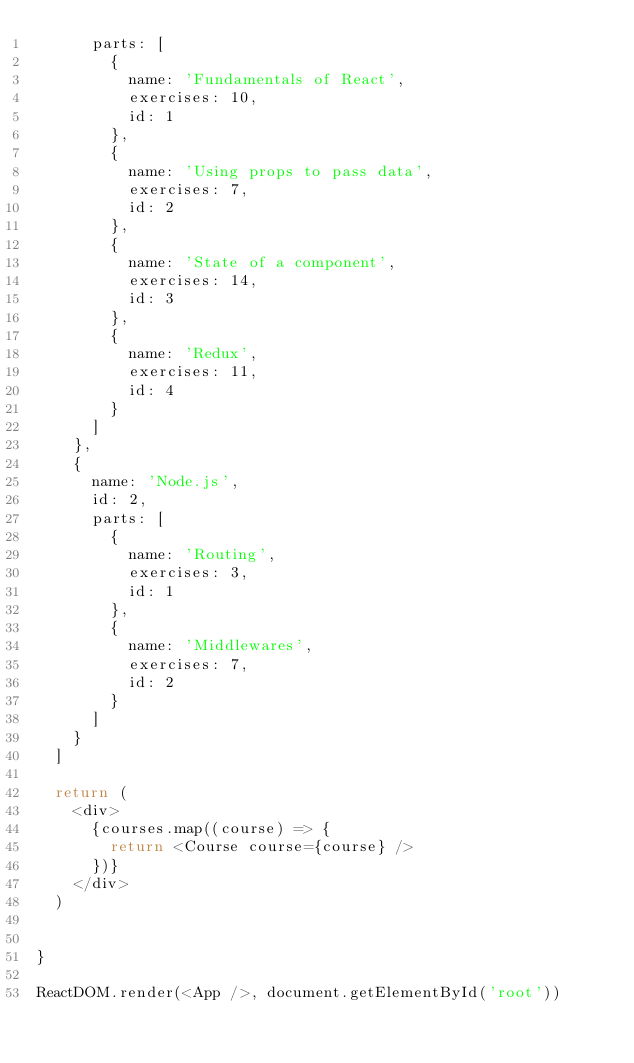Convert code to text. <code><loc_0><loc_0><loc_500><loc_500><_JavaScript_>      parts: [
        {
          name: 'Fundamentals of React',
          exercises: 10,
          id: 1
        },
        {
          name: 'Using props to pass data',
          exercises: 7,
          id: 2
        },
        {
          name: 'State of a component',
          exercises: 14,
          id: 3
        },
        {
          name: 'Redux',
          exercises: 11,
          id: 4
        }
      ]
    }, 
    {
      name: 'Node.js',
      id: 2,
      parts: [
        {
          name: 'Routing',
          exercises: 3,
          id: 1
        },
        {
          name: 'Middlewares',
          exercises: 7,
          id: 2
        }
      ]
    }
  ]

  return (
    <div>
      {courses.map((course) => {
        return <Course course={course} />
      })}
    </div>
  )
  
  
}

ReactDOM.render(<App />, document.getElementById('root'))
</code> 